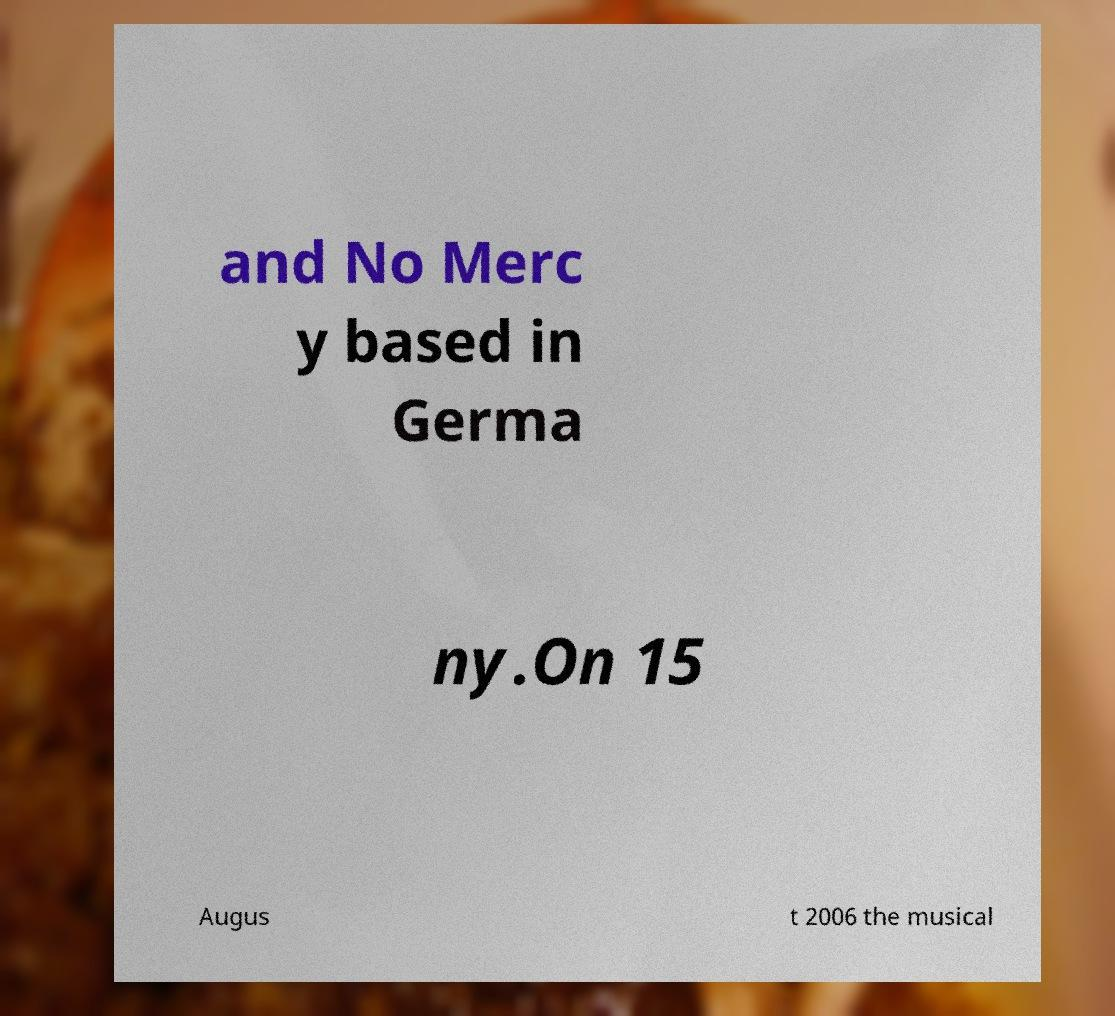There's text embedded in this image that I need extracted. Can you transcribe it verbatim? and No Merc y based in Germa ny.On 15 Augus t 2006 the musical 